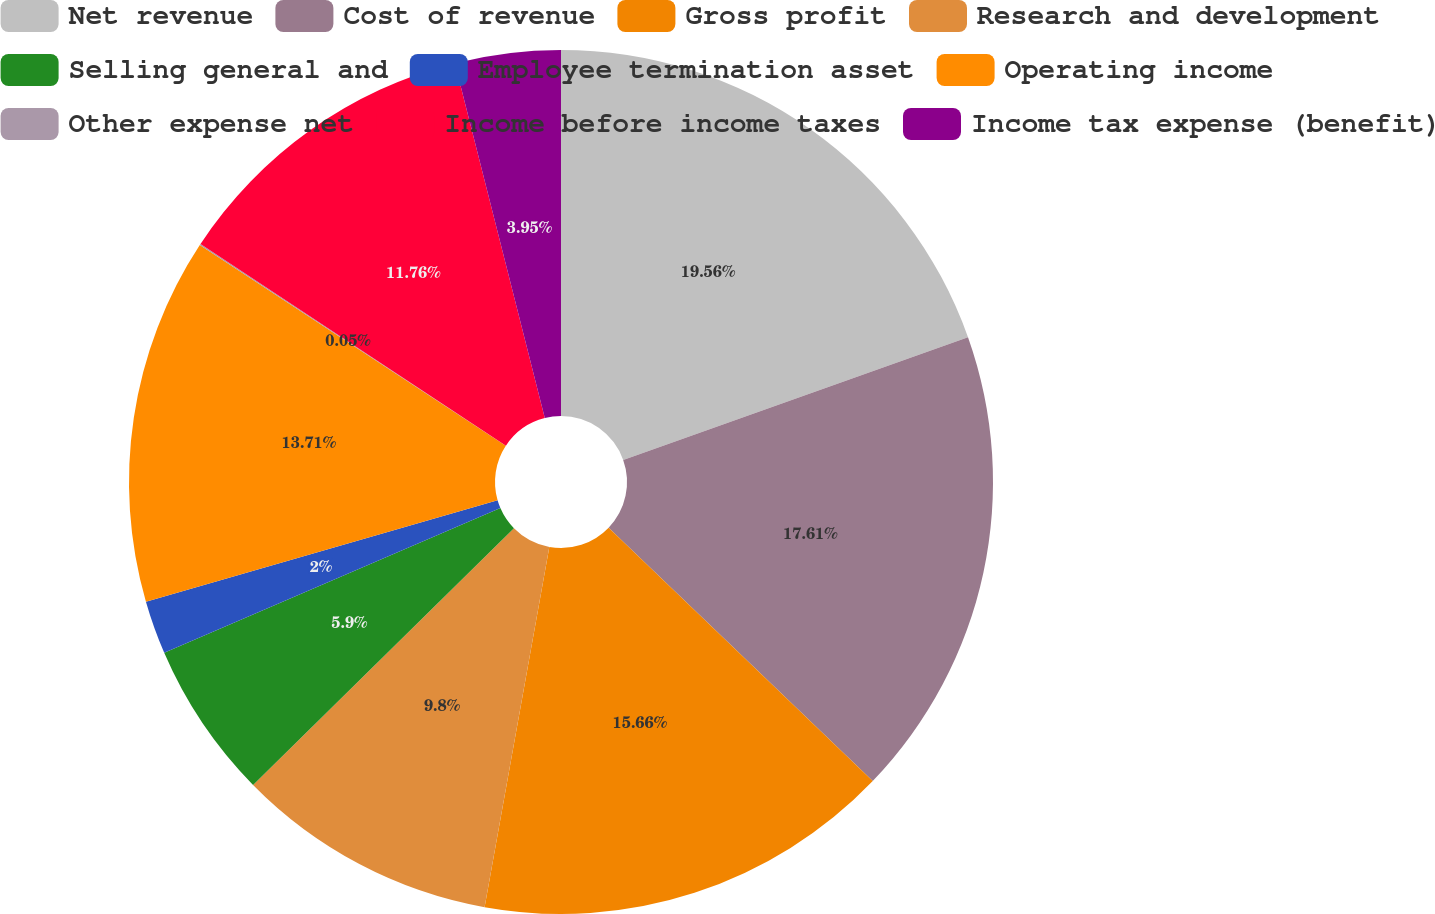Convert chart. <chart><loc_0><loc_0><loc_500><loc_500><pie_chart><fcel>Net revenue<fcel>Cost of revenue<fcel>Gross profit<fcel>Research and development<fcel>Selling general and<fcel>Employee termination asset<fcel>Operating income<fcel>Other expense net<fcel>Income before income taxes<fcel>Income tax expense (benefit)<nl><fcel>19.56%<fcel>17.61%<fcel>15.66%<fcel>9.8%<fcel>5.9%<fcel>2.0%<fcel>13.71%<fcel>0.05%<fcel>11.76%<fcel>3.95%<nl></chart> 